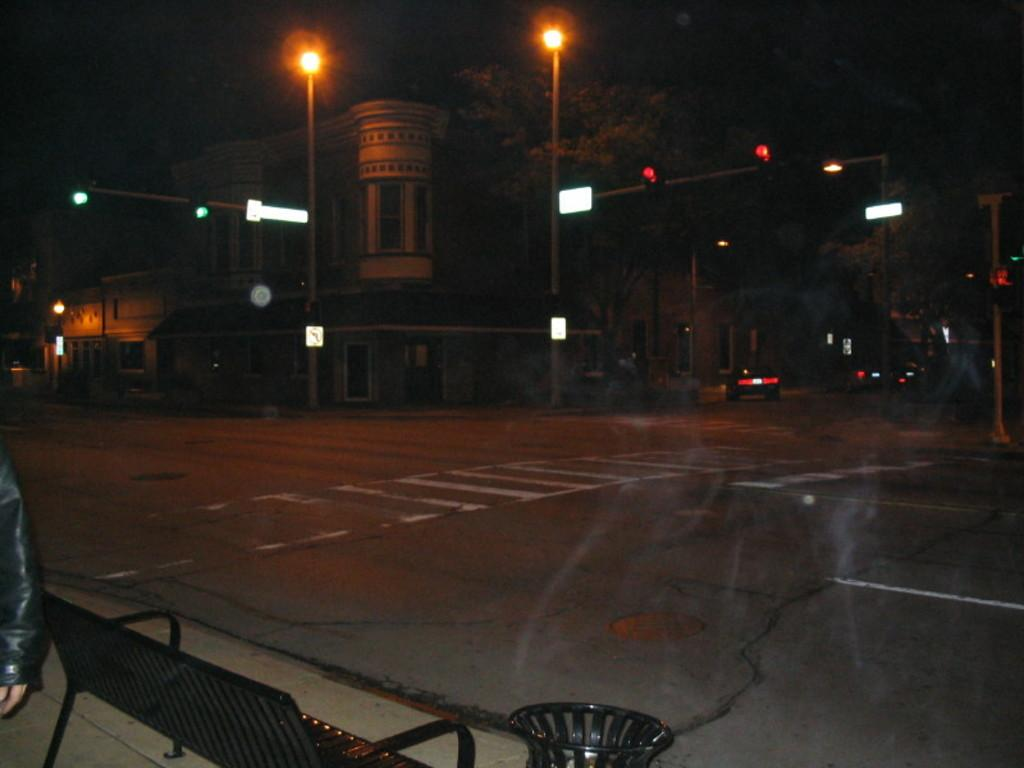What is the main feature of the image? There is a road in the image. What can be found on the left side of the image? There is a bench on the left side of the image. What helps to illuminate the road at night? There are street lights in the image. What is moving along the road in the image? There are cars on the road in the image. What structures are visible in the background? There are buildings in the image. What flavor of pancake is being served on the bench in the image? There is no pancake present in the image, so it is not possible to determine its flavor. 